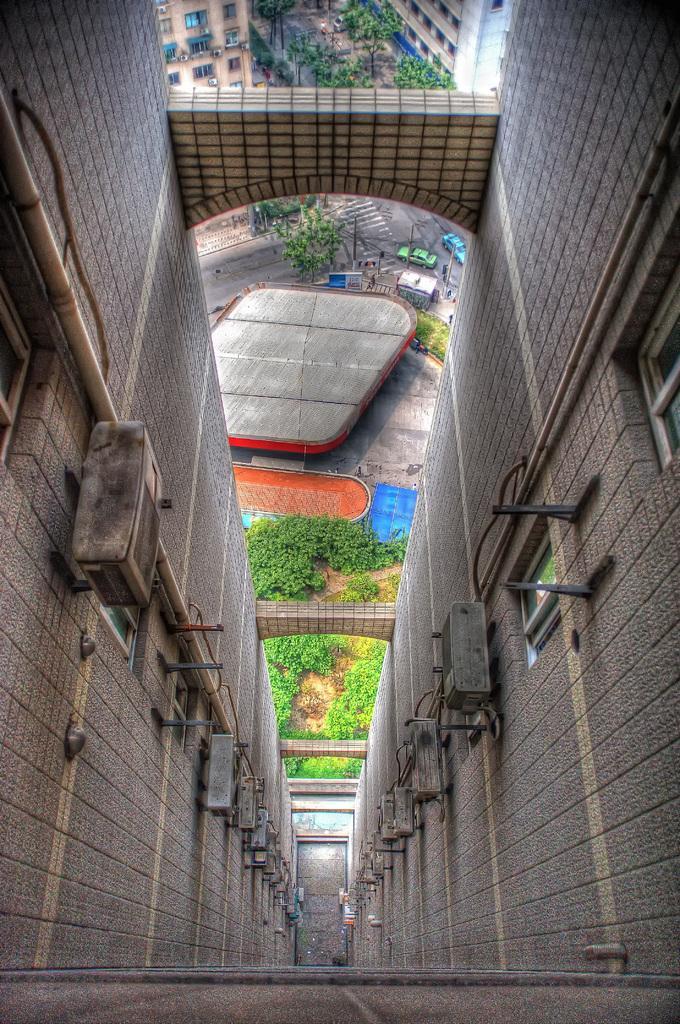Describe this image in one or two sentences. In this image I can see a picture which is taken from the top of the building. I can see few windows, a pipe and few objects to the building. In the background I can see few trees, the road, few vehicles on the road, few poles and few buildings. 